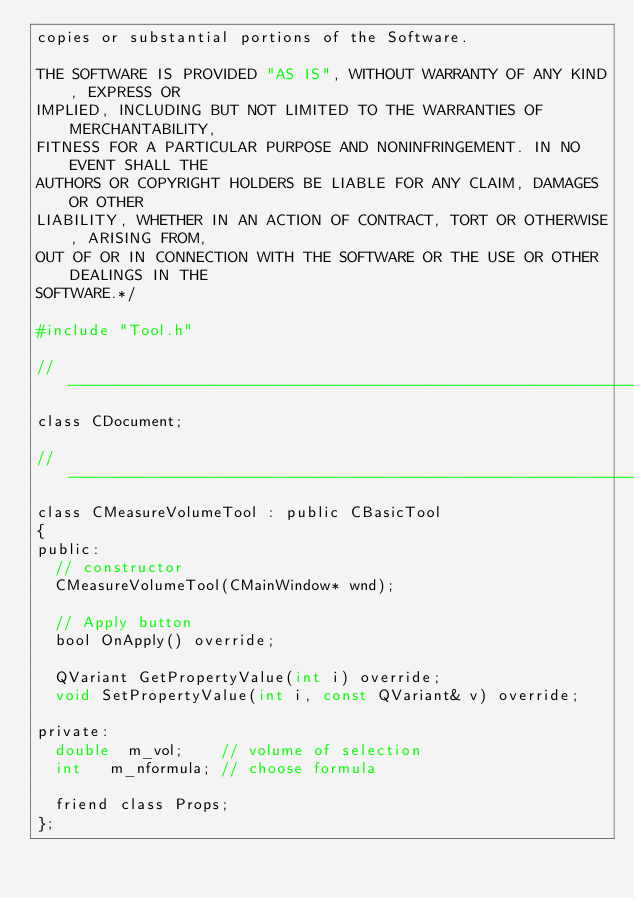Convert code to text. <code><loc_0><loc_0><loc_500><loc_500><_C_>copies or substantial portions of the Software.

THE SOFTWARE IS PROVIDED "AS IS", WITHOUT WARRANTY OF ANY KIND, EXPRESS OR
IMPLIED, INCLUDING BUT NOT LIMITED TO THE WARRANTIES OF MERCHANTABILITY,
FITNESS FOR A PARTICULAR PURPOSE AND NONINFRINGEMENT. IN NO EVENT SHALL THE
AUTHORS OR COPYRIGHT HOLDERS BE LIABLE FOR ANY CLAIM, DAMAGES OR OTHER
LIABILITY, WHETHER IN AN ACTION OF CONTRACT, TORT OR OTHERWISE, ARISING FROM,
OUT OF OR IN CONNECTION WITH THE SOFTWARE OR THE USE OR OTHER DEALINGS IN THE
SOFTWARE.*/

#include "Tool.h"

//-----------------------------------------------------------------------------
class CDocument;

//-----------------------------------------------------------------------------
class CMeasureVolumeTool : public CBasicTool
{
public:
	// constructor
	CMeasureVolumeTool(CMainWindow* wnd);

	// Apply button
	bool OnApply() override;

	QVariant GetPropertyValue(int i) override;
	void SetPropertyValue(int i, const QVariant& v) override;

private:
	double	m_vol;		// volume of selection
	int		m_nformula;	// choose formula

	friend class Props;
};
</code> 